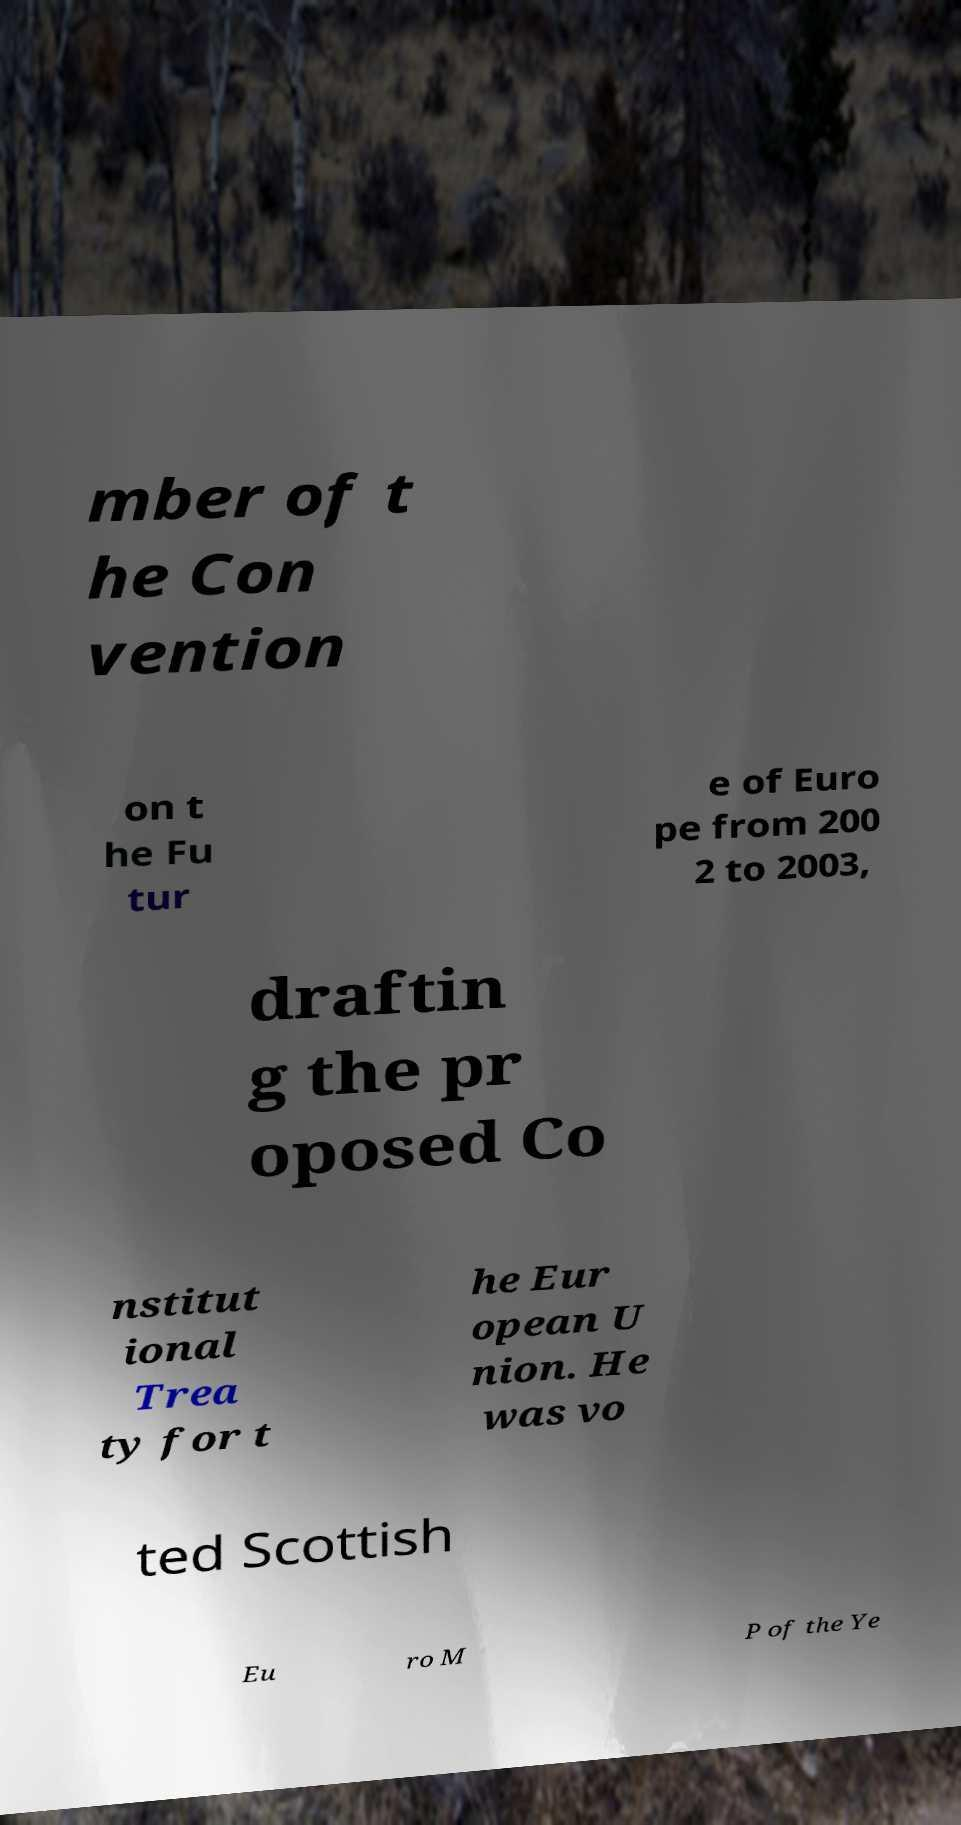What messages or text are displayed in this image? I need them in a readable, typed format. mber of t he Con vention on t he Fu tur e of Euro pe from 200 2 to 2003, draftin g the pr oposed Co nstitut ional Trea ty for t he Eur opean U nion. He was vo ted Scottish Eu ro M P of the Ye 